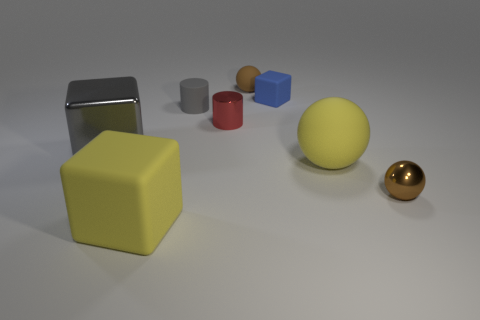Is there a gray rubber object that has the same shape as the tiny red shiny object?
Provide a succinct answer. Yes. What is the shape of the small gray object?
Ensure brevity in your answer.  Cylinder. Are there more gray objects that are in front of the tiny red cylinder than small red metal objects in front of the yellow rubber cube?
Provide a succinct answer. Yes. What number of other things are the same size as the red cylinder?
Provide a short and direct response. 4. What is the material of the tiny thing that is both in front of the tiny matte block and right of the red cylinder?
Provide a short and direct response. Metal. What material is the gray thing that is the same shape as the blue thing?
Keep it short and to the point. Metal. What number of big gray things are right of the yellow thing that is on the left side of the brown sphere behind the small blue thing?
Your answer should be very brief. 0. Are there any other things that have the same color as the small rubber ball?
Give a very brief answer. Yes. How many objects are in front of the red cylinder and on the left side of the tiny blue object?
Keep it short and to the point. 2. There is a brown sphere that is behind the red shiny object; is its size the same as the matte ball that is in front of the large shiny block?
Offer a terse response. No. 